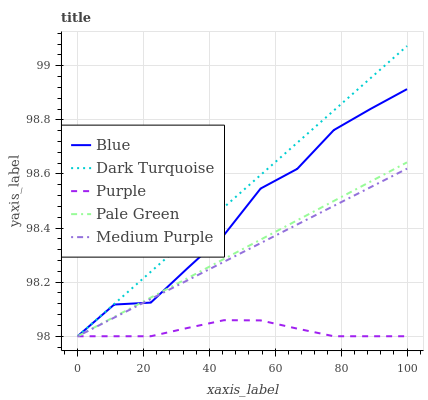Does Purple have the minimum area under the curve?
Answer yes or no. Yes. Does Dark Turquoise have the maximum area under the curve?
Answer yes or no. Yes. Does Medium Purple have the minimum area under the curve?
Answer yes or no. No. Does Medium Purple have the maximum area under the curve?
Answer yes or no. No. Is Dark Turquoise the smoothest?
Answer yes or no. Yes. Is Blue the roughest?
Answer yes or no. Yes. Is Medium Purple the smoothest?
Answer yes or no. No. Is Medium Purple the roughest?
Answer yes or no. No. Does Blue have the lowest value?
Answer yes or no. Yes. Does Dark Turquoise have the highest value?
Answer yes or no. Yes. Does Medium Purple have the highest value?
Answer yes or no. No. Does Purple intersect Pale Green?
Answer yes or no. Yes. Is Purple less than Pale Green?
Answer yes or no. No. Is Purple greater than Pale Green?
Answer yes or no. No. 